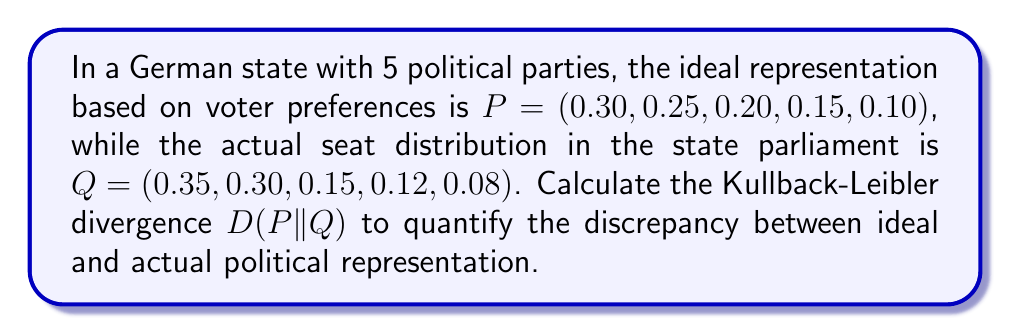Solve this math problem. To solve this problem, we need to use the Kullback-Leibler divergence formula:

$$ D(P||Q) = \sum_{i=1}^{n} P(i) \log \left(\frac{P(i)}{Q(i)}\right) $$

Where:
- $P(i)$ is the probability of the i-th event in the ideal distribution
- $Q(i)$ is the probability of the i-th event in the actual distribution
- $n$ is the number of events (in this case, political parties)

Let's calculate each term of the sum:

1. For i = 1: $0.30 \log(\frac{0.30}{0.35}) = 0.30 \times (-0.0620) = -0.0186$
2. For i = 2: $0.25 \log(\frac{0.25}{0.30}) = 0.25 \times (-0.1823) = -0.0456$
3. For i = 3: $0.20 \log(\frac{0.20}{0.15}) = 0.20 \times 0.2877 = 0.0575$
4. For i = 4: $0.15 \log(\frac{0.15}{0.12}) = 0.15 \times 0.2231 = 0.0335$
5. For i = 5: $0.10 \log(\frac{0.10}{0.08}) = 0.10 \times 0.2231 = 0.0223$

Now, we sum all these terms:

$$ D(P||Q) = -0.0186 - 0.0456 + 0.0575 + 0.0335 + 0.0223 = 0.0491 $$

The Kullback-Leibler divergence between the ideal and actual political representation is approximately 0.0491 bits.
Answer: $D(P||Q) \approx 0.0491$ bits 